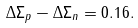<formula> <loc_0><loc_0><loc_500><loc_500>\Delta \Sigma _ { p } - \Delta \Sigma _ { n } = 0 . 1 6 .</formula> 